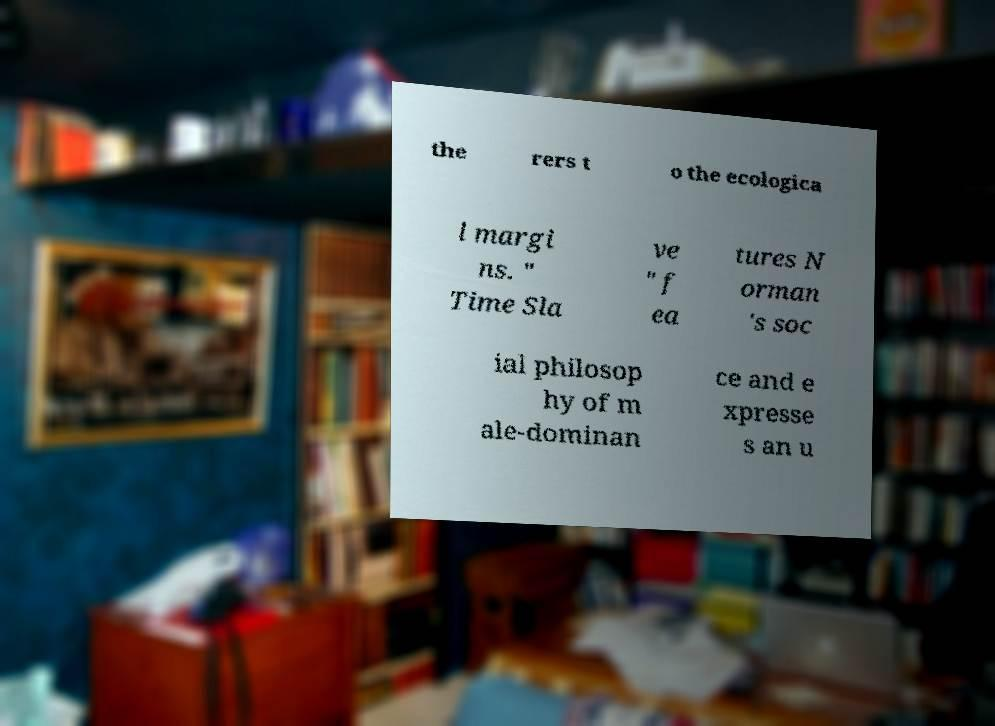There's text embedded in this image that I need extracted. Can you transcribe it verbatim? the rers t o the ecologica l margi ns. " Time Sla ve " f ea tures N orman 's soc ial philosop hy of m ale-dominan ce and e xpresse s an u 